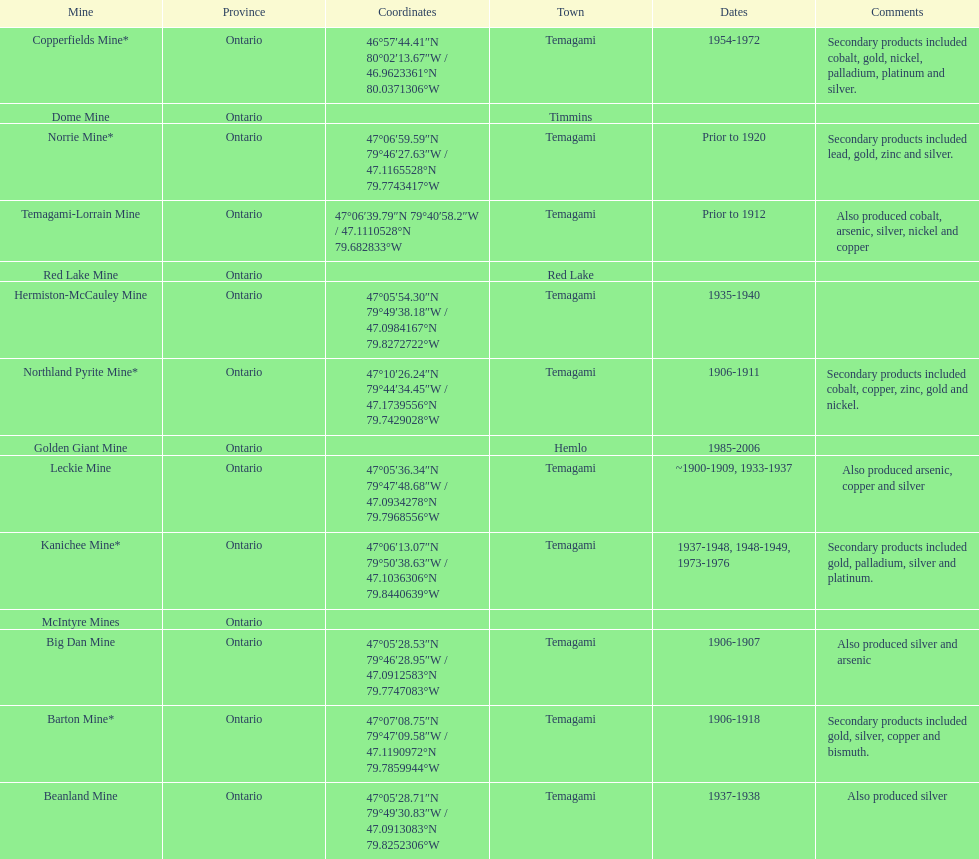Parse the table in full. {'header': ['Mine', 'Province', 'Coordinates', 'Town', 'Dates', 'Comments'], 'rows': [['Copperfields Mine*', 'Ontario', '46°57′44.41″N 80°02′13.67″W\ufeff / \ufeff46.9623361°N 80.0371306°W', 'Temagami', '1954-1972', 'Secondary products included cobalt, gold, nickel, palladium, platinum and silver.'], ['Dome Mine', 'Ontario', '', 'Timmins', '', ''], ['Norrie Mine*', 'Ontario', '47°06′59.59″N 79°46′27.63″W\ufeff / \ufeff47.1165528°N 79.7743417°W', 'Temagami', 'Prior to 1920', 'Secondary products included lead, gold, zinc and silver.'], ['Temagami-Lorrain Mine', 'Ontario', '47°06′39.79″N 79°40′58.2″W\ufeff / \ufeff47.1110528°N 79.682833°W', 'Temagami', 'Prior to 1912', 'Also produced cobalt, arsenic, silver, nickel and copper'], ['Red Lake Mine', 'Ontario', '', 'Red Lake', '', ''], ['Hermiston-McCauley Mine', 'Ontario', '47°05′54.30″N 79°49′38.18″W\ufeff / \ufeff47.0984167°N 79.8272722°W', 'Temagami', '1935-1940', ''], ['Northland Pyrite Mine*', 'Ontario', '47°10′26.24″N 79°44′34.45″W\ufeff / \ufeff47.1739556°N 79.7429028°W', 'Temagami', '1906-1911', 'Secondary products included cobalt, copper, zinc, gold and nickel.'], ['Golden Giant Mine', 'Ontario', '', 'Hemlo', '1985-2006', ''], ['Leckie Mine', 'Ontario', '47°05′36.34″N 79°47′48.68″W\ufeff / \ufeff47.0934278°N 79.7968556°W', 'Temagami', '~1900-1909, 1933-1937', 'Also produced arsenic, copper and silver'], ['Kanichee Mine*', 'Ontario', '47°06′13.07″N 79°50′38.63″W\ufeff / \ufeff47.1036306°N 79.8440639°W', 'Temagami', '1937-1948, 1948-1949, 1973-1976', 'Secondary products included gold, palladium, silver and platinum.'], ['McIntyre Mines', 'Ontario', '', '', '', ''], ['Big Dan Mine', 'Ontario', '47°05′28.53″N 79°46′28.95″W\ufeff / \ufeff47.0912583°N 79.7747083°W', 'Temagami', '1906-1907', 'Also produced silver and arsenic'], ['Barton Mine*', 'Ontario', '47°07′08.75″N 79°47′09.58″W\ufeff / \ufeff47.1190972°N 79.7859944°W', 'Temagami', '1906-1918', 'Secondary products included gold, silver, copper and bismuth.'], ['Beanland Mine', 'Ontario', '47°05′28.71″N 79°49′30.83″W\ufeff / \ufeff47.0913083°N 79.8252306°W', 'Temagami', '1937-1938', 'Also produced silver']]} Name a gold mine that was open at least 10 years. Barton Mine. 